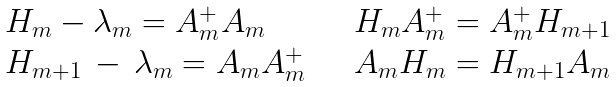<formula> <loc_0><loc_0><loc_500><loc_500>\begin{array} { l l } H _ { m } - \lambda _ { m } = A _ { m } ^ { + } A _ { m } \quad & H _ { m } A _ { m } ^ { + } = A _ { m } ^ { + } H _ { m + 1 } \\ H _ { m + 1 } \, - \, \lambda _ { m } = A _ { m } A _ { m } ^ { + } \quad & A _ { m } H _ { m } = H _ { m + 1 } A _ { m } \end{array}</formula> 